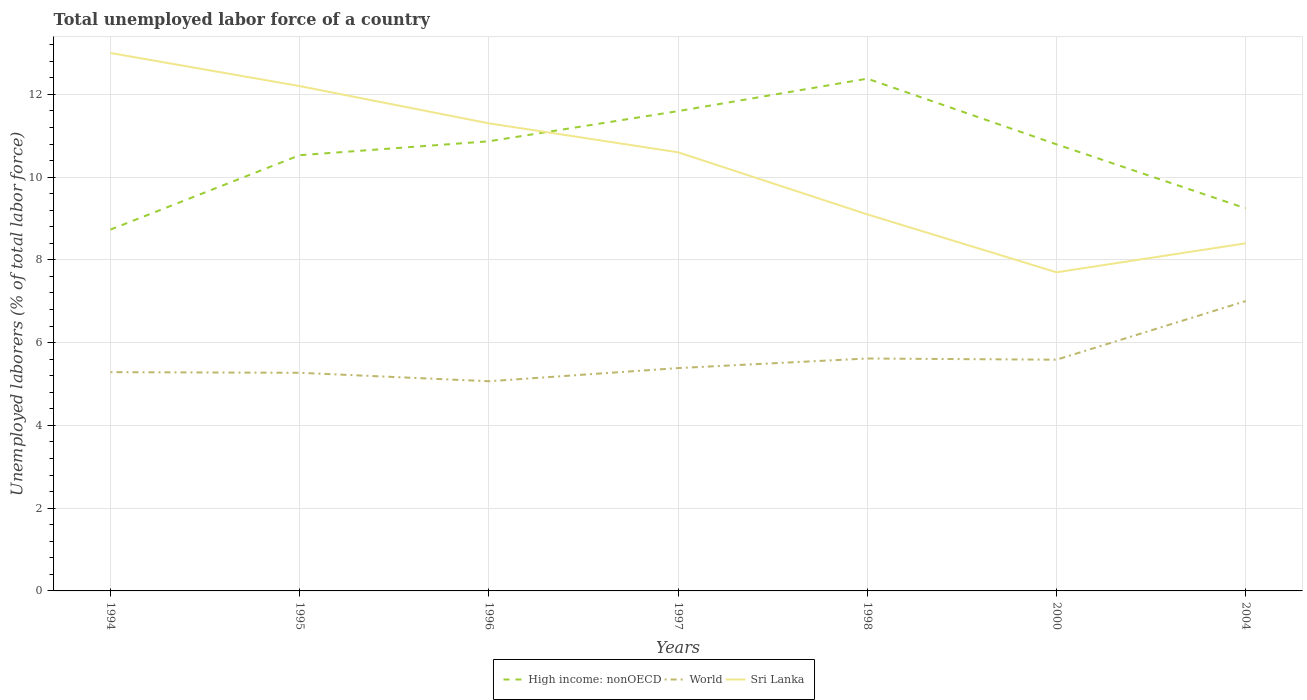Is the number of lines equal to the number of legend labels?
Make the answer very short. Yes. Across all years, what is the maximum total unemployed labor force in Sri Lanka?
Your response must be concise. 7.7. What is the total total unemployed labor force in Sri Lanka in the graph?
Provide a succinct answer. 3.1. What is the difference between the highest and the second highest total unemployed labor force in High income: nonOECD?
Keep it short and to the point. 3.65. What is the difference between the highest and the lowest total unemployed labor force in World?
Offer a very short reply. 2. Is the total unemployed labor force in High income: nonOECD strictly greater than the total unemployed labor force in World over the years?
Your answer should be compact. No. How many lines are there?
Give a very brief answer. 3. How many years are there in the graph?
Keep it short and to the point. 7. Are the values on the major ticks of Y-axis written in scientific E-notation?
Your answer should be compact. No. Does the graph contain any zero values?
Your answer should be compact. No. Where does the legend appear in the graph?
Give a very brief answer. Bottom center. How are the legend labels stacked?
Ensure brevity in your answer.  Horizontal. What is the title of the graph?
Provide a short and direct response. Total unemployed labor force of a country. What is the label or title of the X-axis?
Provide a short and direct response. Years. What is the label or title of the Y-axis?
Give a very brief answer. Unemployed laborers (% of total labor force). What is the Unemployed laborers (% of total labor force) of High income: nonOECD in 1994?
Give a very brief answer. 8.73. What is the Unemployed laborers (% of total labor force) in World in 1994?
Offer a terse response. 5.29. What is the Unemployed laborers (% of total labor force) of High income: nonOECD in 1995?
Give a very brief answer. 10.53. What is the Unemployed laborers (% of total labor force) of World in 1995?
Your response must be concise. 5.27. What is the Unemployed laborers (% of total labor force) of Sri Lanka in 1995?
Make the answer very short. 12.2. What is the Unemployed laborers (% of total labor force) in High income: nonOECD in 1996?
Provide a short and direct response. 10.87. What is the Unemployed laborers (% of total labor force) in World in 1996?
Make the answer very short. 5.07. What is the Unemployed laborers (% of total labor force) of Sri Lanka in 1996?
Your response must be concise. 11.3. What is the Unemployed laborers (% of total labor force) in High income: nonOECD in 1997?
Your answer should be very brief. 11.6. What is the Unemployed laborers (% of total labor force) of World in 1997?
Your answer should be compact. 5.39. What is the Unemployed laborers (% of total labor force) in Sri Lanka in 1997?
Provide a succinct answer. 10.6. What is the Unemployed laborers (% of total labor force) in High income: nonOECD in 1998?
Your response must be concise. 12.38. What is the Unemployed laborers (% of total labor force) in World in 1998?
Give a very brief answer. 5.62. What is the Unemployed laborers (% of total labor force) of Sri Lanka in 1998?
Provide a short and direct response. 9.1. What is the Unemployed laborers (% of total labor force) in High income: nonOECD in 2000?
Your answer should be very brief. 10.79. What is the Unemployed laborers (% of total labor force) of World in 2000?
Your answer should be very brief. 5.59. What is the Unemployed laborers (% of total labor force) in Sri Lanka in 2000?
Provide a succinct answer. 7.7. What is the Unemployed laborers (% of total labor force) of High income: nonOECD in 2004?
Offer a very short reply. 9.25. What is the Unemployed laborers (% of total labor force) in World in 2004?
Your response must be concise. 7.01. What is the Unemployed laborers (% of total labor force) in Sri Lanka in 2004?
Keep it short and to the point. 8.4. Across all years, what is the maximum Unemployed laborers (% of total labor force) of High income: nonOECD?
Your answer should be compact. 12.38. Across all years, what is the maximum Unemployed laborers (% of total labor force) in World?
Keep it short and to the point. 7.01. Across all years, what is the minimum Unemployed laborers (% of total labor force) of High income: nonOECD?
Provide a succinct answer. 8.73. Across all years, what is the minimum Unemployed laborers (% of total labor force) of World?
Your response must be concise. 5.07. Across all years, what is the minimum Unemployed laborers (% of total labor force) of Sri Lanka?
Keep it short and to the point. 7.7. What is the total Unemployed laborers (% of total labor force) of High income: nonOECD in the graph?
Make the answer very short. 74.14. What is the total Unemployed laborers (% of total labor force) of World in the graph?
Your answer should be compact. 39.22. What is the total Unemployed laborers (% of total labor force) in Sri Lanka in the graph?
Offer a very short reply. 72.3. What is the difference between the Unemployed laborers (% of total labor force) in High income: nonOECD in 1994 and that in 1995?
Your answer should be very brief. -1.8. What is the difference between the Unemployed laborers (% of total labor force) of World in 1994 and that in 1995?
Provide a succinct answer. 0.02. What is the difference between the Unemployed laborers (% of total labor force) of High income: nonOECD in 1994 and that in 1996?
Provide a short and direct response. -2.13. What is the difference between the Unemployed laborers (% of total labor force) of World in 1994 and that in 1996?
Give a very brief answer. 0.22. What is the difference between the Unemployed laborers (% of total labor force) in High income: nonOECD in 1994 and that in 1997?
Provide a short and direct response. -2.86. What is the difference between the Unemployed laborers (% of total labor force) in World in 1994 and that in 1997?
Your answer should be compact. -0.1. What is the difference between the Unemployed laborers (% of total labor force) of High income: nonOECD in 1994 and that in 1998?
Make the answer very short. -3.65. What is the difference between the Unemployed laborers (% of total labor force) of World in 1994 and that in 1998?
Ensure brevity in your answer.  -0.33. What is the difference between the Unemployed laborers (% of total labor force) in High income: nonOECD in 1994 and that in 2000?
Your response must be concise. -2.06. What is the difference between the Unemployed laborers (% of total labor force) in World in 1994 and that in 2000?
Give a very brief answer. -0.3. What is the difference between the Unemployed laborers (% of total labor force) of High income: nonOECD in 1994 and that in 2004?
Ensure brevity in your answer.  -0.51. What is the difference between the Unemployed laborers (% of total labor force) in World in 1994 and that in 2004?
Your answer should be very brief. -1.72. What is the difference between the Unemployed laborers (% of total labor force) of High income: nonOECD in 1995 and that in 1996?
Offer a terse response. -0.34. What is the difference between the Unemployed laborers (% of total labor force) of World in 1995 and that in 1996?
Your answer should be very brief. 0.2. What is the difference between the Unemployed laborers (% of total labor force) in Sri Lanka in 1995 and that in 1996?
Give a very brief answer. 0.9. What is the difference between the Unemployed laborers (% of total labor force) in High income: nonOECD in 1995 and that in 1997?
Give a very brief answer. -1.07. What is the difference between the Unemployed laborers (% of total labor force) of World in 1995 and that in 1997?
Your answer should be very brief. -0.11. What is the difference between the Unemployed laborers (% of total labor force) of High income: nonOECD in 1995 and that in 1998?
Provide a short and direct response. -1.85. What is the difference between the Unemployed laborers (% of total labor force) in World in 1995 and that in 1998?
Your answer should be very brief. -0.34. What is the difference between the Unemployed laborers (% of total labor force) of Sri Lanka in 1995 and that in 1998?
Offer a very short reply. 3.1. What is the difference between the Unemployed laborers (% of total labor force) of High income: nonOECD in 1995 and that in 2000?
Provide a succinct answer. -0.26. What is the difference between the Unemployed laborers (% of total labor force) of World in 1995 and that in 2000?
Your answer should be compact. -0.32. What is the difference between the Unemployed laborers (% of total labor force) of Sri Lanka in 1995 and that in 2000?
Your answer should be very brief. 4.5. What is the difference between the Unemployed laborers (% of total labor force) in High income: nonOECD in 1995 and that in 2004?
Offer a very short reply. 1.28. What is the difference between the Unemployed laborers (% of total labor force) in World in 1995 and that in 2004?
Offer a very short reply. -1.73. What is the difference between the Unemployed laborers (% of total labor force) in Sri Lanka in 1995 and that in 2004?
Make the answer very short. 3.8. What is the difference between the Unemployed laborers (% of total labor force) of High income: nonOECD in 1996 and that in 1997?
Offer a terse response. -0.73. What is the difference between the Unemployed laborers (% of total labor force) of World in 1996 and that in 1997?
Your answer should be compact. -0.32. What is the difference between the Unemployed laborers (% of total labor force) in High income: nonOECD in 1996 and that in 1998?
Your response must be concise. -1.51. What is the difference between the Unemployed laborers (% of total labor force) in World in 1996 and that in 1998?
Your response must be concise. -0.55. What is the difference between the Unemployed laborers (% of total labor force) in High income: nonOECD in 1996 and that in 2000?
Keep it short and to the point. 0.07. What is the difference between the Unemployed laborers (% of total labor force) of World in 1996 and that in 2000?
Offer a very short reply. -0.52. What is the difference between the Unemployed laborers (% of total labor force) of High income: nonOECD in 1996 and that in 2004?
Keep it short and to the point. 1.62. What is the difference between the Unemployed laborers (% of total labor force) in World in 1996 and that in 2004?
Ensure brevity in your answer.  -1.94. What is the difference between the Unemployed laborers (% of total labor force) in Sri Lanka in 1996 and that in 2004?
Keep it short and to the point. 2.9. What is the difference between the Unemployed laborers (% of total labor force) in High income: nonOECD in 1997 and that in 1998?
Your response must be concise. -0.78. What is the difference between the Unemployed laborers (% of total labor force) in World in 1997 and that in 1998?
Provide a succinct answer. -0.23. What is the difference between the Unemployed laborers (% of total labor force) in High income: nonOECD in 1997 and that in 2000?
Provide a succinct answer. 0.8. What is the difference between the Unemployed laborers (% of total labor force) in World in 1997 and that in 2000?
Provide a short and direct response. -0.2. What is the difference between the Unemployed laborers (% of total labor force) in High income: nonOECD in 1997 and that in 2004?
Make the answer very short. 2.35. What is the difference between the Unemployed laborers (% of total labor force) of World in 1997 and that in 2004?
Provide a short and direct response. -1.62. What is the difference between the Unemployed laborers (% of total labor force) in High income: nonOECD in 1998 and that in 2000?
Your answer should be very brief. 1.59. What is the difference between the Unemployed laborers (% of total labor force) in World in 1998 and that in 2000?
Give a very brief answer. 0.03. What is the difference between the Unemployed laborers (% of total labor force) in High income: nonOECD in 1998 and that in 2004?
Offer a terse response. 3.13. What is the difference between the Unemployed laborers (% of total labor force) in World in 1998 and that in 2004?
Your answer should be compact. -1.39. What is the difference between the Unemployed laborers (% of total labor force) of High income: nonOECD in 2000 and that in 2004?
Ensure brevity in your answer.  1.55. What is the difference between the Unemployed laborers (% of total labor force) in World in 2000 and that in 2004?
Provide a succinct answer. -1.42. What is the difference between the Unemployed laborers (% of total labor force) in High income: nonOECD in 1994 and the Unemployed laborers (% of total labor force) in World in 1995?
Your answer should be very brief. 3.46. What is the difference between the Unemployed laborers (% of total labor force) in High income: nonOECD in 1994 and the Unemployed laborers (% of total labor force) in Sri Lanka in 1995?
Give a very brief answer. -3.47. What is the difference between the Unemployed laborers (% of total labor force) in World in 1994 and the Unemployed laborers (% of total labor force) in Sri Lanka in 1995?
Provide a short and direct response. -6.91. What is the difference between the Unemployed laborers (% of total labor force) in High income: nonOECD in 1994 and the Unemployed laborers (% of total labor force) in World in 1996?
Your answer should be compact. 3.67. What is the difference between the Unemployed laborers (% of total labor force) of High income: nonOECD in 1994 and the Unemployed laborers (% of total labor force) of Sri Lanka in 1996?
Your response must be concise. -2.57. What is the difference between the Unemployed laborers (% of total labor force) of World in 1994 and the Unemployed laborers (% of total labor force) of Sri Lanka in 1996?
Offer a very short reply. -6.01. What is the difference between the Unemployed laborers (% of total labor force) of High income: nonOECD in 1994 and the Unemployed laborers (% of total labor force) of World in 1997?
Your answer should be very brief. 3.35. What is the difference between the Unemployed laborers (% of total labor force) in High income: nonOECD in 1994 and the Unemployed laborers (% of total labor force) in Sri Lanka in 1997?
Offer a terse response. -1.87. What is the difference between the Unemployed laborers (% of total labor force) in World in 1994 and the Unemployed laborers (% of total labor force) in Sri Lanka in 1997?
Give a very brief answer. -5.31. What is the difference between the Unemployed laborers (% of total labor force) in High income: nonOECD in 1994 and the Unemployed laborers (% of total labor force) in World in 1998?
Your answer should be compact. 3.12. What is the difference between the Unemployed laborers (% of total labor force) of High income: nonOECD in 1994 and the Unemployed laborers (% of total labor force) of Sri Lanka in 1998?
Ensure brevity in your answer.  -0.37. What is the difference between the Unemployed laborers (% of total labor force) in World in 1994 and the Unemployed laborers (% of total labor force) in Sri Lanka in 1998?
Provide a short and direct response. -3.81. What is the difference between the Unemployed laborers (% of total labor force) in High income: nonOECD in 1994 and the Unemployed laborers (% of total labor force) in World in 2000?
Keep it short and to the point. 3.14. What is the difference between the Unemployed laborers (% of total labor force) of High income: nonOECD in 1994 and the Unemployed laborers (% of total labor force) of Sri Lanka in 2000?
Your answer should be very brief. 1.03. What is the difference between the Unemployed laborers (% of total labor force) of World in 1994 and the Unemployed laborers (% of total labor force) of Sri Lanka in 2000?
Provide a short and direct response. -2.41. What is the difference between the Unemployed laborers (% of total labor force) in High income: nonOECD in 1994 and the Unemployed laborers (% of total labor force) in World in 2004?
Ensure brevity in your answer.  1.73. What is the difference between the Unemployed laborers (% of total labor force) of High income: nonOECD in 1994 and the Unemployed laborers (% of total labor force) of Sri Lanka in 2004?
Provide a short and direct response. 0.33. What is the difference between the Unemployed laborers (% of total labor force) of World in 1994 and the Unemployed laborers (% of total labor force) of Sri Lanka in 2004?
Provide a succinct answer. -3.11. What is the difference between the Unemployed laborers (% of total labor force) in High income: nonOECD in 1995 and the Unemployed laborers (% of total labor force) in World in 1996?
Your answer should be compact. 5.46. What is the difference between the Unemployed laborers (% of total labor force) in High income: nonOECD in 1995 and the Unemployed laborers (% of total labor force) in Sri Lanka in 1996?
Ensure brevity in your answer.  -0.77. What is the difference between the Unemployed laborers (% of total labor force) of World in 1995 and the Unemployed laborers (% of total labor force) of Sri Lanka in 1996?
Make the answer very short. -6.03. What is the difference between the Unemployed laborers (% of total labor force) of High income: nonOECD in 1995 and the Unemployed laborers (% of total labor force) of World in 1997?
Offer a very short reply. 5.14. What is the difference between the Unemployed laborers (% of total labor force) of High income: nonOECD in 1995 and the Unemployed laborers (% of total labor force) of Sri Lanka in 1997?
Your answer should be compact. -0.07. What is the difference between the Unemployed laborers (% of total labor force) in World in 1995 and the Unemployed laborers (% of total labor force) in Sri Lanka in 1997?
Give a very brief answer. -5.33. What is the difference between the Unemployed laborers (% of total labor force) of High income: nonOECD in 1995 and the Unemployed laborers (% of total labor force) of World in 1998?
Provide a succinct answer. 4.91. What is the difference between the Unemployed laborers (% of total labor force) of High income: nonOECD in 1995 and the Unemployed laborers (% of total labor force) of Sri Lanka in 1998?
Provide a short and direct response. 1.43. What is the difference between the Unemployed laborers (% of total labor force) of World in 1995 and the Unemployed laborers (% of total labor force) of Sri Lanka in 1998?
Offer a very short reply. -3.83. What is the difference between the Unemployed laborers (% of total labor force) of High income: nonOECD in 1995 and the Unemployed laborers (% of total labor force) of World in 2000?
Offer a terse response. 4.94. What is the difference between the Unemployed laborers (% of total labor force) of High income: nonOECD in 1995 and the Unemployed laborers (% of total labor force) of Sri Lanka in 2000?
Give a very brief answer. 2.83. What is the difference between the Unemployed laborers (% of total labor force) of World in 1995 and the Unemployed laborers (% of total labor force) of Sri Lanka in 2000?
Your answer should be compact. -2.43. What is the difference between the Unemployed laborers (% of total labor force) in High income: nonOECD in 1995 and the Unemployed laborers (% of total labor force) in World in 2004?
Keep it short and to the point. 3.52. What is the difference between the Unemployed laborers (% of total labor force) in High income: nonOECD in 1995 and the Unemployed laborers (% of total labor force) in Sri Lanka in 2004?
Offer a very short reply. 2.13. What is the difference between the Unemployed laborers (% of total labor force) of World in 1995 and the Unemployed laborers (% of total labor force) of Sri Lanka in 2004?
Provide a short and direct response. -3.13. What is the difference between the Unemployed laborers (% of total labor force) in High income: nonOECD in 1996 and the Unemployed laborers (% of total labor force) in World in 1997?
Give a very brief answer. 5.48. What is the difference between the Unemployed laborers (% of total labor force) in High income: nonOECD in 1996 and the Unemployed laborers (% of total labor force) in Sri Lanka in 1997?
Give a very brief answer. 0.27. What is the difference between the Unemployed laborers (% of total labor force) in World in 1996 and the Unemployed laborers (% of total labor force) in Sri Lanka in 1997?
Provide a short and direct response. -5.53. What is the difference between the Unemployed laborers (% of total labor force) in High income: nonOECD in 1996 and the Unemployed laborers (% of total labor force) in World in 1998?
Provide a succinct answer. 5.25. What is the difference between the Unemployed laborers (% of total labor force) in High income: nonOECD in 1996 and the Unemployed laborers (% of total labor force) in Sri Lanka in 1998?
Your answer should be very brief. 1.77. What is the difference between the Unemployed laborers (% of total labor force) of World in 1996 and the Unemployed laborers (% of total labor force) of Sri Lanka in 1998?
Offer a very short reply. -4.03. What is the difference between the Unemployed laborers (% of total labor force) in High income: nonOECD in 1996 and the Unemployed laborers (% of total labor force) in World in 2000?
Offer a terse response. 5.28. What is the difference between the Unemployed laborers (% of total labor force) in High income: nonOECD in 1996 and the Unemployed laborers (% of total labor force) in Sri Lanka in 2000?
Offer a very short reply. 3.17. What is the difference between the Unemployed laborers (% of total labor force) in World in 1996 and the Unemployed laborers (% of total labor force) in Sri Lanka in 2000?
Make the answer very short. -2.63. What is the difference between the Unemployed laborers (% of total labor force) in High income: nonOECD in 1996 and the Unemployed laborers (% of total labor force) in World in 2004?
Your answer should be compact. 3.86. What is the difference between the Unemployed laborers (% of total labor force) of High income: nonOECD in 1996 and the Unemployed laborers (% of total labor force) of Sri Lanka in 2004?
Your answer should be compact. 2.47. What is the difference between the Unemployed laborers (% of total labor force) in World in 1996 and the Unemployed laborers (% of total labor force) in Sri Lanka in 2004?
Give a very brief answer. -3.33. What is the difference between the Unemployed laborers (% of total labor force) in High income: nonOECD in 1997 and the Unemployed laborers (% of total labor force) in World in 1998?
Your answer should be compact. 5.98. What is the difference between the Unemployed laborers (% of total labor force) in High income: nonOECD in 1997 and the Unemployed laborers (% of total labor force) in Sri Lanka in 1998?
Your answer should be very brief. 2.5. What is the difference between the Unemployed laborers (% of total labor force) in World in 1997 and the Unemployed laborers (% of total labor force) in Sri Lanka in 1998?
Provide a succinct answer. -3.71. What is the difference between the Unemployed laborers (% of total labor force) of High income: nonOECD in 1997 and the Unemployed laborers (% of total labor force) of World in 2000?
Offer a very short reply. 6.01. What is the difference between the Unemployed laborers (% of total labor force) in High income: nonOECD in 1997 and the Unemployed laborers (% of total labor force) in Sri Lanka in 2000?
Give a very brief answer. 3.9. What is the difference between the Unemployed laborers (% of total labor force) in World in 1997 and the Unemployed laborers (% of total labor force) in Sri Lanka in 2000?
Your answer should be very brief. -2.31. What is the difference between the Unemployed laborers (% of total labor force) of High income: nonOECD in 1997 and the Unemployed laborers (% of total labor force) of World in 2004?
Provide a short and direct response. 4.59. What is the difference between the Unemployed laborers (% of total labor force) of High income: nonOECD in 1997 and the Unemployed laborers (% of total labor force) of Sri Lanka in 2004?
Provide a short and direct response. 3.2. What is the difference between the Unemployed laborers (% of total labor force) in World in 1997 and the Unemployed laborers (% of total labor force) in Sri Lanka in 2004?
Provide a short and direct response. -3.01. What is the difference between the Unemployed laborers (% of total labor force) of High income: nonOECD in 1998 and the Unemployed laborers (% of total labor force) of World in 2000?
Give a very brief answer. 6.79. What is the difference between the Unemployed laborers (% of total labor force) in High income: nonOECD in 1998 and the Unemployed laborers (% of total labor force) in Sri Lanka in 2000?
Make the answer very short. 4.68. What is the difference between the Unemployed laborers (% of total labor force) in World in 1998 and the Unemployed laborers (% of total labor force) in Sri Lanka in 2000?
Provide a succinct answer. -2.08. What is the difference between the Unemployed laborers (% of total labor force) of High income: nonOECD in 1998 and the Unemployed laborers (% of total labor force) of World in 2004?
Your answer should be very brief. 5.37. What is the difference between the Unemployed laborers (% of total labor force) in High income: nonOECD in 1998 and the Unemployed laborers (% of total labor force) in Sri Lanka in 2004?
Give a very brief answer. 3.98. What is the difference between the Unemployed laborers (% of total labor force) in World in 1998 and the Unemployed laborers (% of total labor force) in Sri Lanka in 2004?
Give a very brief answer. -2.78. What is the difference between the Unemployed laborers (% of total labor force) of High income: nonOECD in 2000 and the Unemployed laborers (% of total labor force) of World in 2004?
Provide a short and direct response. 3.79. What is the difference between the Unemployed laborers (% of total labor force) in High income: nonOECD in 2000 and the Unemployed laborers (% of total labor force) in Sri Lanka in 2004?
Make the answer very short. 2.39. What is the difference between the Unemployed laborers (% of total labor force) of World in 2000 and the Unemployed laborers (% of total labor force) of Sri Lanka in 2004?
Offer a terse response. -2.81. What is the average Unemployed laborers (% of total labor force) of High income: nonOECD per year?
Provide a short and direct response. 10.59. What is the average Unemployed laborers (% of total labor force) of World per year?
Your response must be concise. 5.6. What is the average Unemployed laborers (% of total labor force) in Sri Lanka per year?
Your answer should be very brief. 10.33. In the year 1994, what is the difference between the Unemployed laborers (% of total labor force) in High income: nonOECD and Unemployed laborers (% of total labor force) in World?
Ensure brevity in your answer.  3.45. In the year 1994, what is the difference between the Unemployed laborers (% of total labor force) in High income: nonOECD and Unemployed laborers (% of total labor force) in Sri Lanka?
Provide a short and direct response. -4.27. In the year 1994, what is the difference between the Unemployed laborers (% of total labor force) of World and Unemployed laborers (% of total labor force) of Sri Lanka?
Your answer should be compact. -7.71. In the year 1995, what is the difference between the Unemployed laborers (% of total labor force) of High income: nonOECD and Unemployed laborers (% of total labor force) of World?
Provide a succinct answer. 5.26. In the year 1995, what is the difference between the Unemployed laborers (% of total labor force) in High income: nonOECD and Unemployed laborers (% of total labor force) in Sri Lanka?
Make the answer very short. -1.67. In the year 1995, what is the difference between the Unemployed laborers (% of total labor force) of World and Unemployed laborers (% of total labor force) of Sri Lanka?
Provide a short and direct response. -6.93. In the year 1996, what is the difference between the Unemployed laborers (% of total labor force) of High income: nonOECD and Unemployed laborers (% of total labor force) of World?
Offer a very short reply. 5.8. In the year 1996, what is the difference between the Unemployed laborers (% of total labor force) in High income: nonOECD and Unemployed laborers (% of total labor force) in Sri Lanka?
Provide a short and direct response. -0.43. In the year 1996, what is the difference between the Unemployed laborers (% of total labor force) in World and Unemployed laborers (% of total labor force) in Sri Lanka?
Ensure brevity in your answer.  -6.23. In the year 1997, what is the difference between the Unemployed laborers (% of total labor force) in High income: nonOECD and Unemployed laborers (% of total labor force) in World?
Your answer should be compact. 6.21. In the year 1997, what is the difference between the Unemployed laborers (% of total labor force) of World and Unemployed laborers (% of total labor force) of Sri Lanka?
Provide a short and direct response. -5.21. In the year 1998, what is the difference between the Unemployed laborers (% of total labor force) of High income: nonOECD and Unemployed laborers (% of total labor force) of World?
Provide a succinct answer. 6.76. In the year 1998, what is the difference between the Unemployed laborers (% of total labor force) of High income: nonOECD and Unemployed laborers (% of total labor force) of Sri Lanka?
Your answer should be very brief. 3.28. In the year 1998, what is the difference between the Unemployed laborers (% of total labor force) in World and Unemployed laborers (% of total labor force) in Sri Lanka?
Offer a very short reply. -3.48. In the year 2000, what is the difference between the Unemployed laborers (% of total labor force) in High income: nonOECD and Unemployed laborers (% of total labor force) in World?
Offer a terse response. 5.2. In the year 2000, what is the difference between the Unemployed laborers (% of total labor force) of High income: nonOECD and Unemployed laborers (% of total labor force) of Sri Lanka?
Offer a very short reply. 3.09. In the year 2000, what is the difference between the Unemployed laborers (% of total labor force) of World and Unemployed laborers (% of total labor force) of Sri Lanka?
Give a very brief answer. -2.11. In the year 2004, what is the difference between the Unemployed laborers (% of total labor force) in High income: nonOECD and Unemployed laborers (% of total labor force) in World?
Make the answer very short. 2.24. In the year 2004, what is the difference between the Unemployed laborers (% of total labor force) in High income: nonOECD and Unemployed laborers (% of total labor force) in Sri Lanka?
Provide a short and direct response. 0.85. In the year 2004, what is the difference between the Unemployed laborers (% of total labor force) in World and Unemployed laborers (% of total labor force) in Sri Lanka?
Offer a very short reply. -1.4. What is the ratio of the Unemployed laborers (% of total labor force) of High income: nonOECD in 1994 to that in 1995?
Keep it short and to the point. 0.83. What is the ratio of the Unemployed laborers (% of total labor force) in World in 1994 to that in 1995?
Provide a short and direct response. 1. What is the ratio of the Unemployed laborers (% of total labor force) of Sri Lanka in 1994 to that in 1995?
Provide a succinct answer. 1.07. What is the ratio of the Unemployed laborers (% of total labor force) in High income: nonOECD in 1994 to that in 1996?
Your answer should be very brief. 0.8. What is the ratio of the Unemployed laborers (% of total labor force) of World in 1994 to that in 1996?
Ensure brevity in your answer.  1.04. What is the ratio of the Unemployed laborers (% of total labor force) in Sri Lanka in 1994 to that in 1996?
Offer a very short reply. 1.15. What is the ratio of the Unemployed laborers (% of total labor force) in High income: nonOECD in 1994 to that in 1997?
Your response must be concise. 0.75. What is the ratio of the Unemployed laborers (% of total labor force) of World in 1994 to that in 1997?
Provide a succinct answer. 0.98. What is the ratio of the Unemployed laborers (% of total labor force) of Sri Lanka in 1994 to that in 1997?
Your response must be concise. 1.23. What is the ratio of the Unemployed laborers (% of total labor force) in High income: nonOECD in 1994 to that in 1998?
Provide a short and direct response. 0.71. What is the ratio of the Unemployed laborers (% of total labor force) in World in 1994 to that in 1998?
Offer a very short reply. 0.94. What is the ratio of the Unemployed laborers (% of total labor force) of Sri Lanka in 1994 to that in 1998?
Provide a short and direct response. 1.43. What is the ratio of the Unemployed laborers (% of total labor force) in High income: nonOECD in 1994 to that in 2000?
Make the answer very short. 0.81. What is the ratio of the Unemployed laborers (% of total labor force) in World in 1994 to that in 2000?
Your response must be concise. 0.95. What is the ratio of the Unemployed laborers (% of total labor force) of Sri Lanka in 1994 to that in 2000?
Provide a short and direct response. 1.69. What is the ratio of the Unemployed laborers (% of total labor force) in High income: nonOECD in 1994 to that in 2004?
Keep it short and to the point. 0.94. What is the ratio of the Unemployed laborers (% of total labor force) in World in 1994 to that in 2004?
Make the answer very short. 0.75. What is the ratio of the Unemployed laborers (% of total labor force) in Sri Lanka in 1994 to that in 2004?
Provide a succinct answer. 1.55. What is the ratio of the Unemployed laborers (% of total labor force) in World in 1995 to that in 1996?
Ensure brevity in your answer.  1.04. What is the ratio of the Unemployed laborers (% of total labor force) of Sri Lanka in 1995 to that in 1996?
Keep it short and to the point. 1.08. What is the ratio of the Unemployed laborers (% of total labor force) of High income: nonOECD in 1995 to that in 1997?
Your response must be concise. 0.91. What is the ratio of the Unemployed laborers (% of total labor force) of World in 1995 to that in 1997?
Provide a succinct answer. 0.98. What is the ratio of the Unemployed laborers (% of total labor force) in Sri Lanka in 1995 to that in 1997?
Your response must be concise. 1.15. What is the ratio of the Unemployed laborers (% of total labor force) of High income: nonOECD in 1995 to that in 1998?
Your answer should be very brief. 0.85. What is the ratio of the Unemployed laborers (% of total labor force) in World in 1995 to that in 1998?
Offer a terse response. 0.94. What is the ratio of the Unemployed laborers (% of total labor force) of Sri Lanka in 1995 to that in 1998?
Ensure brevity in your answer.  1.34. What is the ratio of the Unemployed laborers (% of total labor force) of High income: nonOECD in 1995 to that in 2000?
Give a very brief answer. 0.98. What is the ratio of the Unemployed laborers (% of total labor force) of World in 1995 to that in 2000?
Ensure brevity in your answer.  0.94. What is the ratio of the Unemployed laborers (% of total labor force) of Sri Lanka in 1995 to that in 2000?
Offer a very short reply. 1.58. What is the ratio of the Unemployed laborers (% of total labor force) in High income: nonOECD in 1995 to that in 2004?
Offer a very short reply. 1.14. What is the ratio of the Unemployed laborers (% of total labor force) of World in 1995 to that in 2004?
Provide a short and direct response. 0.75. What is the ratio of the Unemployed laborers (% of total labor force) of Sri Lanka in 1995 to that in 2004?
Make the answer very short. 1.45. What is the ratio of the Unemployed laborers (% of total labor force) of High income: nonOECD in 1996 to that in 1997?
Keep it short and to the point. 0.94. What is the ratio of the Unemployed laborers (% of total labor force) of World in 1996 to that in 1997?
Offer a very short reply. 0.94. What is the ratio of the Unemployed laborers (% of total labor force) in Sri Lanka in 1996 to that in 1997?
Ensure brevity in your answer.  1.07. What is the ratio of the Unemployed laborers (% of total labor force) of High income: nonOECD in 1996 to that in 1998?
Your answer should be compact. 0.88. What is the ratio of the Unemployed laborers (% of total labor force) in World in 1996 to that in 1998?
Provide a succinct answer. 0.9. What is the ratio of the Unemployed laborers (% of total labor force) in Sri Lanka in 1996 to that in 1998?
Provide a short and direct response. 1.24. What is the ratio of the Unemployed laborers (% of total labor force) of High income: nonOECD in 1996 to that in 2000?
Ensure brevity in your answer.  1.01. What is the ratio of the Unemployed laborers (% of total labor force) of World in 1996 to that in 2000?
Ensure brevity in your answer.  0.91. What is the ratio of the Unemployed laborers (% of total labor force) of Sri Lanka in 1996 to that in 2000?
Your response must be concise. 1.47. What is the ratio of the Unemployed laborers (% of total labor force) in High income: nonOECD in 1996 to that in 2004?
Offer a terse response. 1.18. What is the ratio of the Unemployed laborers (% of total labor force) of World in 1996 to that in 2004?
Your response must be concise. 0.72. What is the ratio of the Unemployed laborers (% of total labor force) of Sri Lanka in 1996 to that in 2004?
Make the answer very short. 1.35. What is the ratio of the Unemployed laborers (% of total labor force) in High income: nonOECD in 1997 to that in 1998?
Your response must be concise. 0.94. What is the ratio of the Unemployed laborers (% of total labor force) of World in 1997 to that in 1998?
Your answer should be compact. 0.96. What is the ratio of the Unemployed laborers (% of total labor force) in Sri Lanka in 1997 to that in 1998?
Offer a terse response. 1.16. What is the ratio of the Unemployed laborers (% of total labor force) of High income: nonOECD in 1997 to that in 2000?
Your answer should be compact. 1.07. What is the ratio of the Unemployed laborers (% of total labor force) of World in 1997 to that in 2000?
Give a very brief answer. 0.96. What is the ratio of the Unemployed laborers (% of total labor force) of Sri Lanka in 1997 to that in 2000?
Keep it short and to the point. 1.38. What is the ratio of the Unemployed laborers (% of total labor force) of High income: nonOECD in 1997 to that in 2004?
Provide a short and direct response. 1.25. What is the ratio of the Unemployed laborers (% of total labor force) in World in 1997 to that in 2004?
Ensure brevity in your answer.  0.77. What is the ratio of the Unemployed laborers (% of total labor force) in Sri Lanka in 1997 to that in 2004?
Provide a short and direct response. 1.26. What is the ratio of the Unemployed laborers (% of total labor force) in High income: nonOECD in 1998 to that in 2000?
Your answer should be very brief. 1.15. What is the ratio of the Unemployed laborers (% of total labor force) of Sri Lanka in 1998 to that in 2000?
Offer a very short reply. 1.18. What is the ratio of the Unemployed laborers (% of total labor force) in High income: nonOECD in 1998 to that in 2004?
Offer a very short reply. 1.34. What is the ratio of the Unemployed laborers (% of total labor force) in World in 1998 to that in 2004?
Offer a terse response. 0.8. What is the ratio of the Unemployed laborers (% of total labor force) in High income: nonOECD in 2000 to that in 2004?
Your answer should be compact. 1.17. What is the ratio of the Unemployed laborers (% of total labor force) in World in 2000 to that in 2004?
Your answer should be compact. 0.8. What is the difference between the highest and the second highest Unemployed laborers (% of total labor force) in High income: nonOECD?
Your response must be concise. 0.78. What is the difference between the highest and the second highest Unemployed laborers (% of total labor force) in World?
Your answer should be compact. 1.39. What is the difference between the highest and the lowest Unemployed laborers (% of total labor force) of High income: nonOECD?
Provide a succinct answer. 3.65. What is the difference between the highest and the lowest Unemployed laborers (% of total labor force) in World?
Offer a very short reply. 1.94. What is the difference between the highest and the lowest Unemployed laborers (% of total labor force) in Sri Lanka?
Make the answer very short. 5.3. 